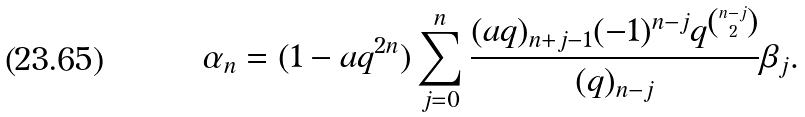<formula> <loc_0><loc_0><loc_500><loc_500>\alpha _ { n } = ( 1 - a q ^ { 2 n } ) \sum _ { j = 0 } ^ { n } \frac { ( a q ) _ { n + j - 1 } ( - 1 ) ^ { n - j } q ^ { \binom { n - j } { 2 } } } { ( q ) _ { n - j } } \beta _ { j } .</formula> 